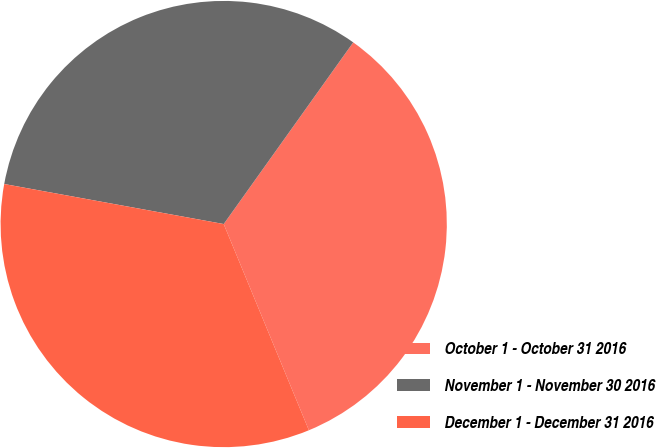Convert chart to OTSL. <chart><loc_0><loc_0><loc_500><loc_500><pie_chart><fcel>October 1 - October 31 2016<fcel>November 1 - November 30 2016<fcel>December 1 - December 31 2016<nl><fcel>33.91%<fcel>31.99%<fcel>34.11%<nl></chart> 